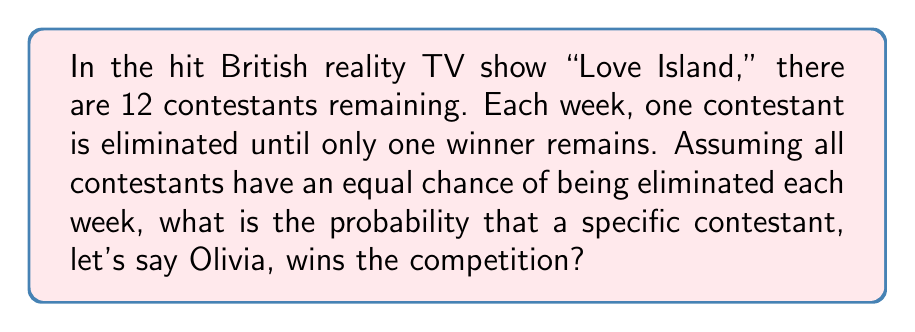Show me your answer to this math problem. To solve this problem, we need to consider the following:

1. Olivia needs to survive all elimination rounds to win.
2. There are 11 elimination rounds in total (from 12 contestants to 1 winner).
3. In each round, Olivia's probability of surviving is the number of survivors divided by the number of contestants at the start of that round.

Let's calculate the probability step by step:

1. In the first round: $P_1 = \frac{11}{12}$
2. In the second round: $P_2 = \frac{10}{11}$
3. In the third round: $P_3 = \frac{9}{10}$
...
11. In the eleventh (final) round: $P_{11} = \frac{1}{2}$

The overall probability of Olivia winning is the product of all these individual probabilities:

$$P(\text{Olivia wins}) = P_1 \times P_2 \times P_3 \times ... \times P_{11}$$

$$P(\text{Olivia wins}) = \frac{11}{12} \times \frac{10}{11} \times \frac{9}{10} \times ... \times \frac{1}{2}$$

This can be simplified to:

$$P(\text{Olivia wins}) = \frac{1}{12}$$

This makes sense intuitively as well, since with all contestants having an equal chance, each of the 12 contestants has a $\frac{1}{12}$ probability of winning.
Answer: $\frac{1}{12}$ or approximately $0.0833$ or $8.33\%$ 